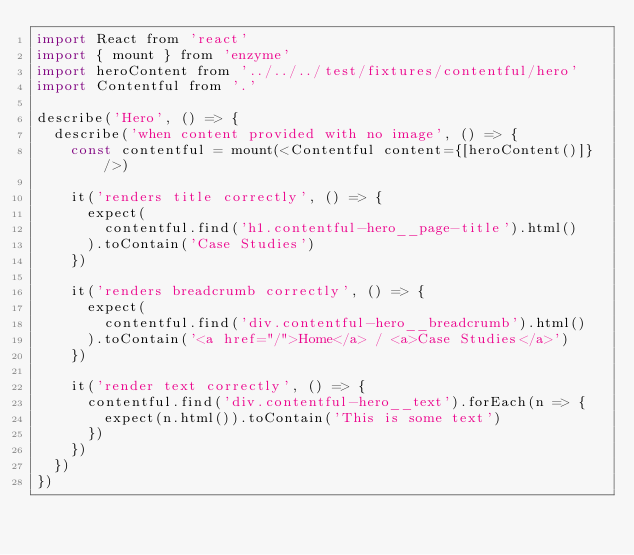<code> <loc_0><loc_0><loc_500><loc_500><_JavaScript_>import React from 'react'
import { mount } from 'enzyme'
import heroContent from '../../../test/fixtures/contentful/hero'
import Contentful from '.'

describe('Hero', () => {
  describe('when content provided with no image', () => {
    const contentful = mount(<Contentful content={[heroContent()]} />)

    it('renders title correctly', () => {
      expect(
        contentful.find('h1.contentful-hero__page-title').html()
      ).toContain('Case Studies')
    })

    it('renders breadcrumb correctly', () => {
      expect(
        contentful.find('div.contentful-hero__breadcrumb').html()
      ).toContain('<a href="/">Home</a> / <a>Case Studies</a>')
    })

    it('render text correctly', () => {
      contentful.find('div.contentful-hero__text').forEach(n => {
        expect(n.html()).toContain('This is some text')
      })
    })
  })
})
</code> 